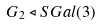<formula> <loc_0><loc_0><loc_500><loc_500>G _ { 2 } \triangleleft S G a l ( 3 )</formula> 